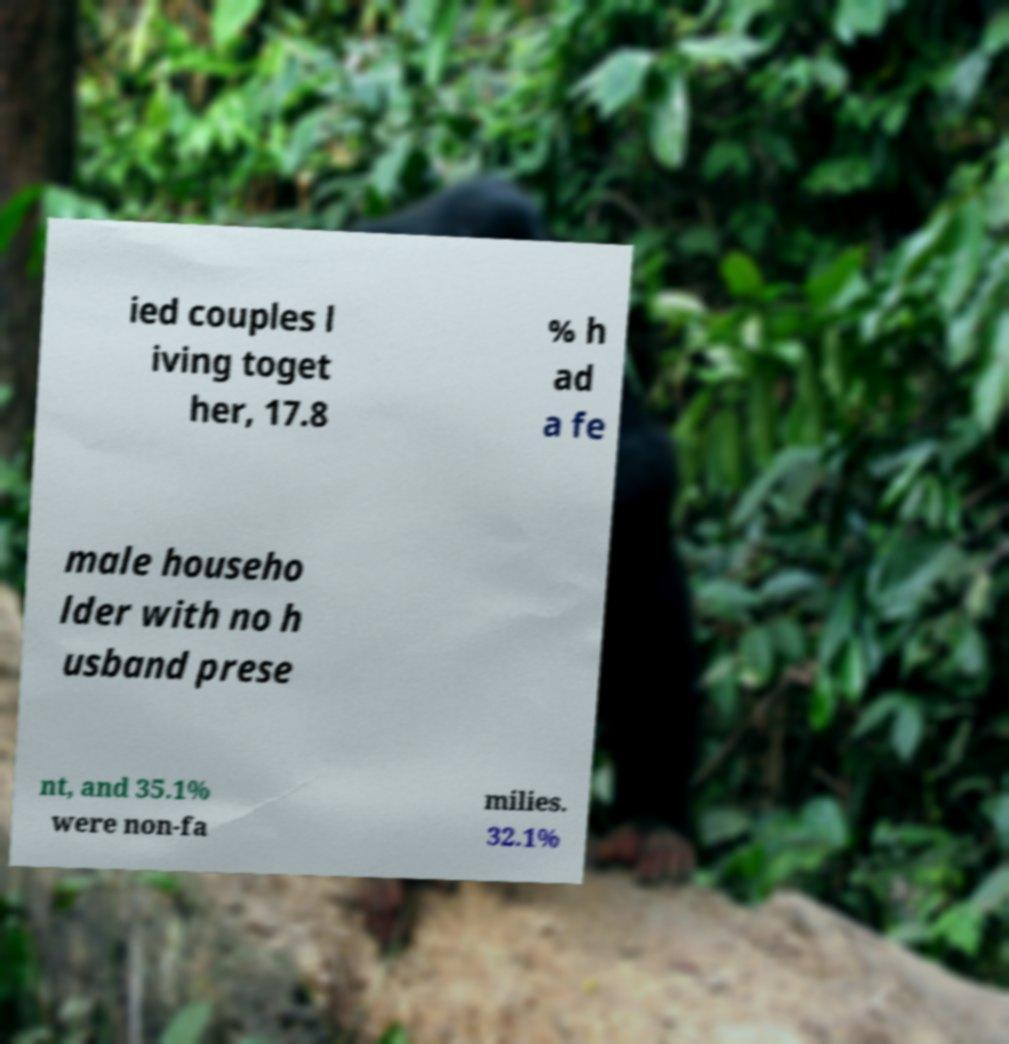There's text embedded in this image that I need extracted. Can you transcribe it verbatim? ied couples l iving toget her, 17.8 % h ad a fe male househo lder with no h usband prese nt, and 35.1% were non-fa milies. 32.1% 